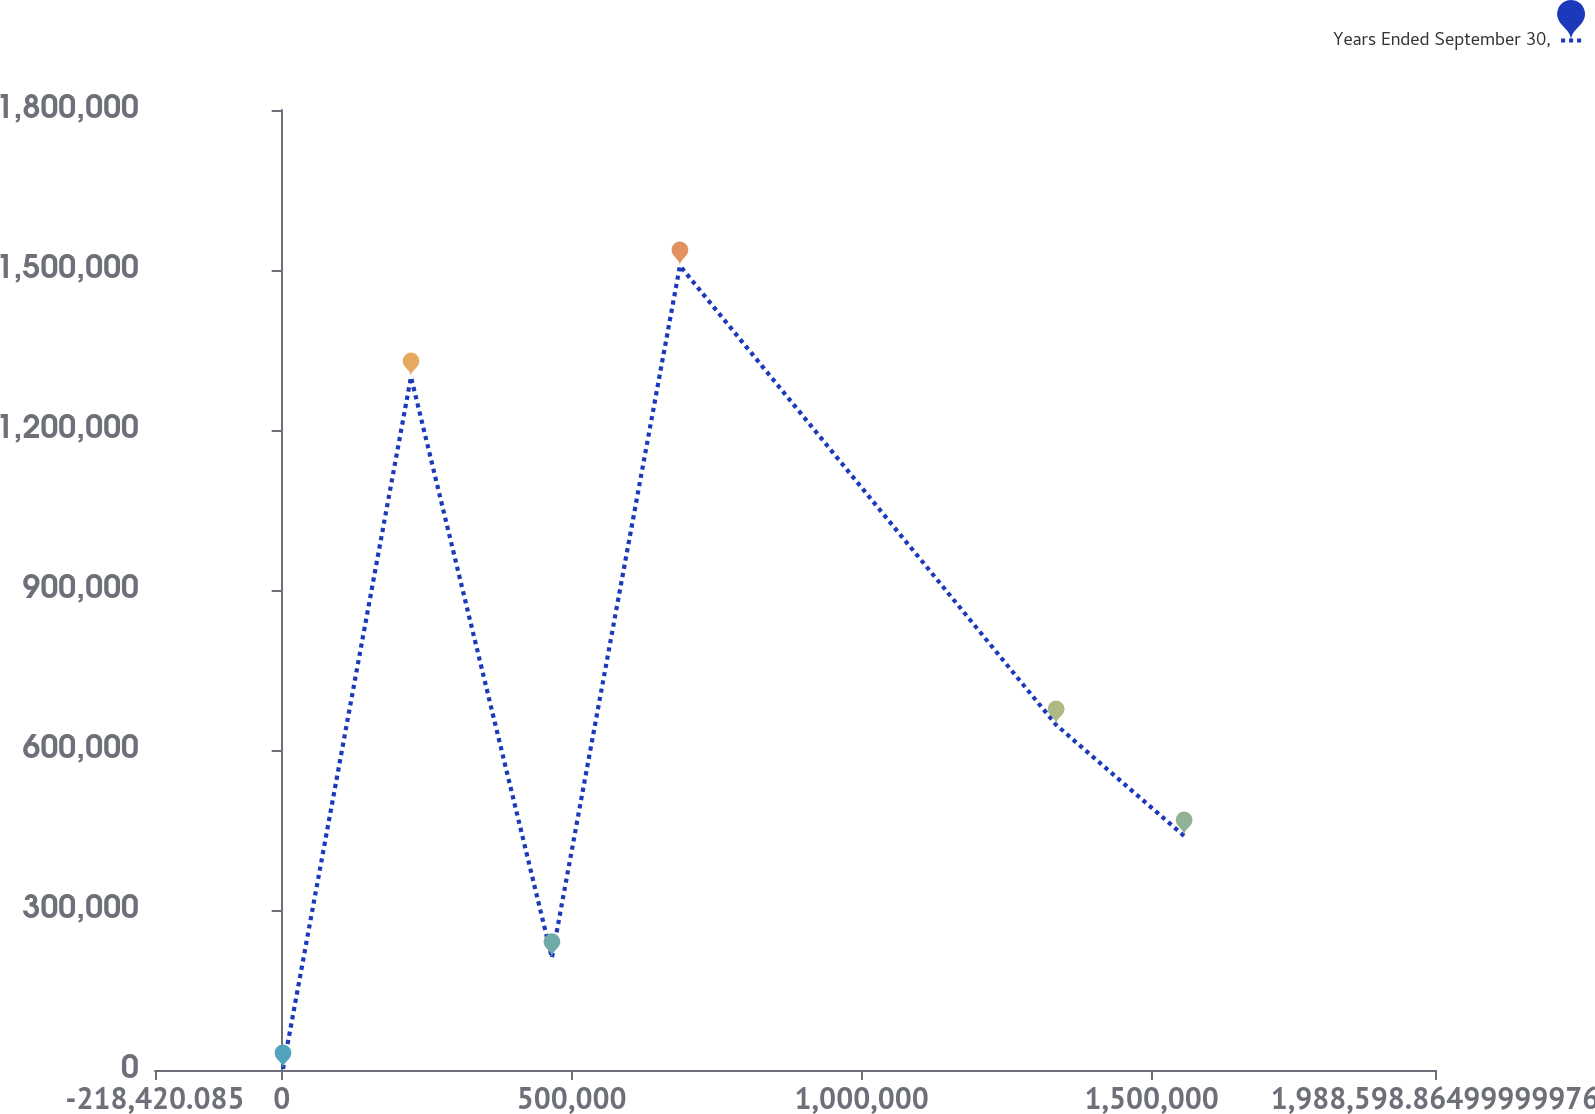Convert chart. <chart><loc_0><loc_0><loc_500><loc_500><line_chart><ecel><fcel>Years Ended September 30,<nl><fcel>2281.81<fcel>2090.75<nl><fcel>222984<fcel>1.2994e+06<nl><fcel>465950<fcel>210446<nl><fcel>686651<fcel>1.50776e+06<nl><fcel>1.33532e+06<fcel>647189<nl><fcel>1.55602e+06<fcel>438834<nl><fcel>2.2093e+06<fcel>2.08564e+06<nl></chart> 